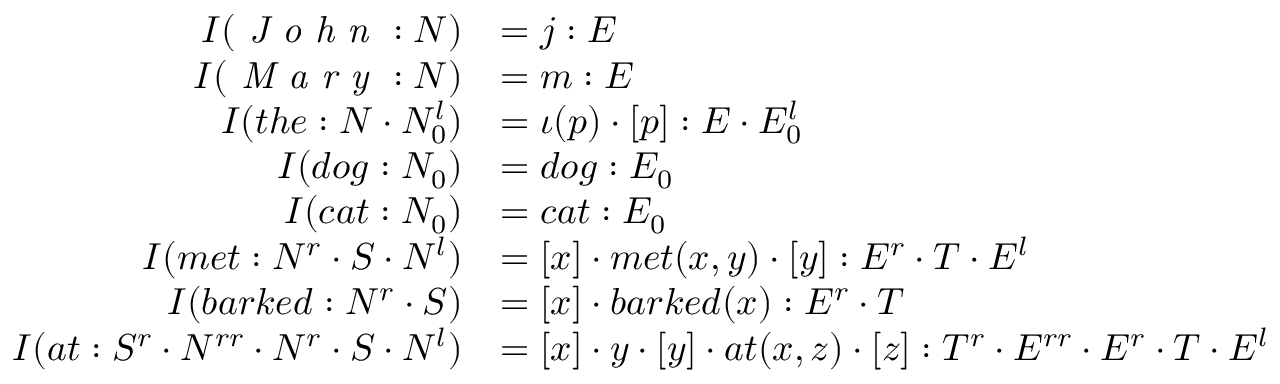<formula> <loc_0><loc_0><loc_500><loc_500>{ \begin{array} { r l } { I ( { J o h n } \colon N ) } & { = j \colon E } \\ { I ( { M a r y } \colon N ) } & { = m \colon E } \\ { I ( t h e \colon N \cdot N _ { 0 } ^ { l } ) } & { = \iota ( p ) \cdot [ p ] \colon E \cdot E _ { 0 } ^ { l } } \\ { I ( d o g \colon N _ { 0 } ) } & { = d o g \colon E _ { 0 } } \\ { I ( c a t \colon N _ { 0 } ) } & { = c a t \colon E _ { 0 } } \\ { I ( m e t \colon N ^ { r } \cdot S \cdot N ^ { l } ) } & { = [ x ] \cdot m e t ( x , y ) \cdot [ y ] \colon E ^ { r } \cdot T \cdot E ^ { l } } \\ { I ( b a r k e d \colon N ^ { r } \cdot S ) } & { = [ x ] \cdot b a r k e d ( x ) \colon E ^ { r } \cdot T } \\ { I ( a t \colon S ^ { r } \cdot N ^ { r r } \cdot N ^ { r } \cdot S \cdot N ^ { l } ) } & { = [ x ] \cdot y \cdot [ y ] \cdot a t ( x , z ) \cdot [ z ] \colon T ^ { r } \cdot E ^ { r r } \cdot E ^ { r } \cdot T \cdot E ^ { l } } \end{array} }</formula> 